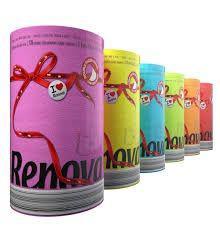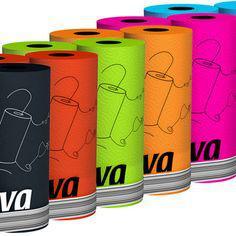The first image is the image on the left, the second image is the image on the right. Examine the images to the left and right. Is the description "In at least one image there are two or more rolls of paper towels in each package." accurate? Answer yes or no. No. The first image is the image on the left, the second image is the image on the right. Evaluate the accuracy of this statement regarding the images: "One of the roll of paper towels is not in its wrapper.". Is it true? Answer yes or no. No. 